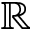Convert formula to latex. <formula><loc_0><loc_0><loc_500><loc_500>\mathbb { R }</formula> 